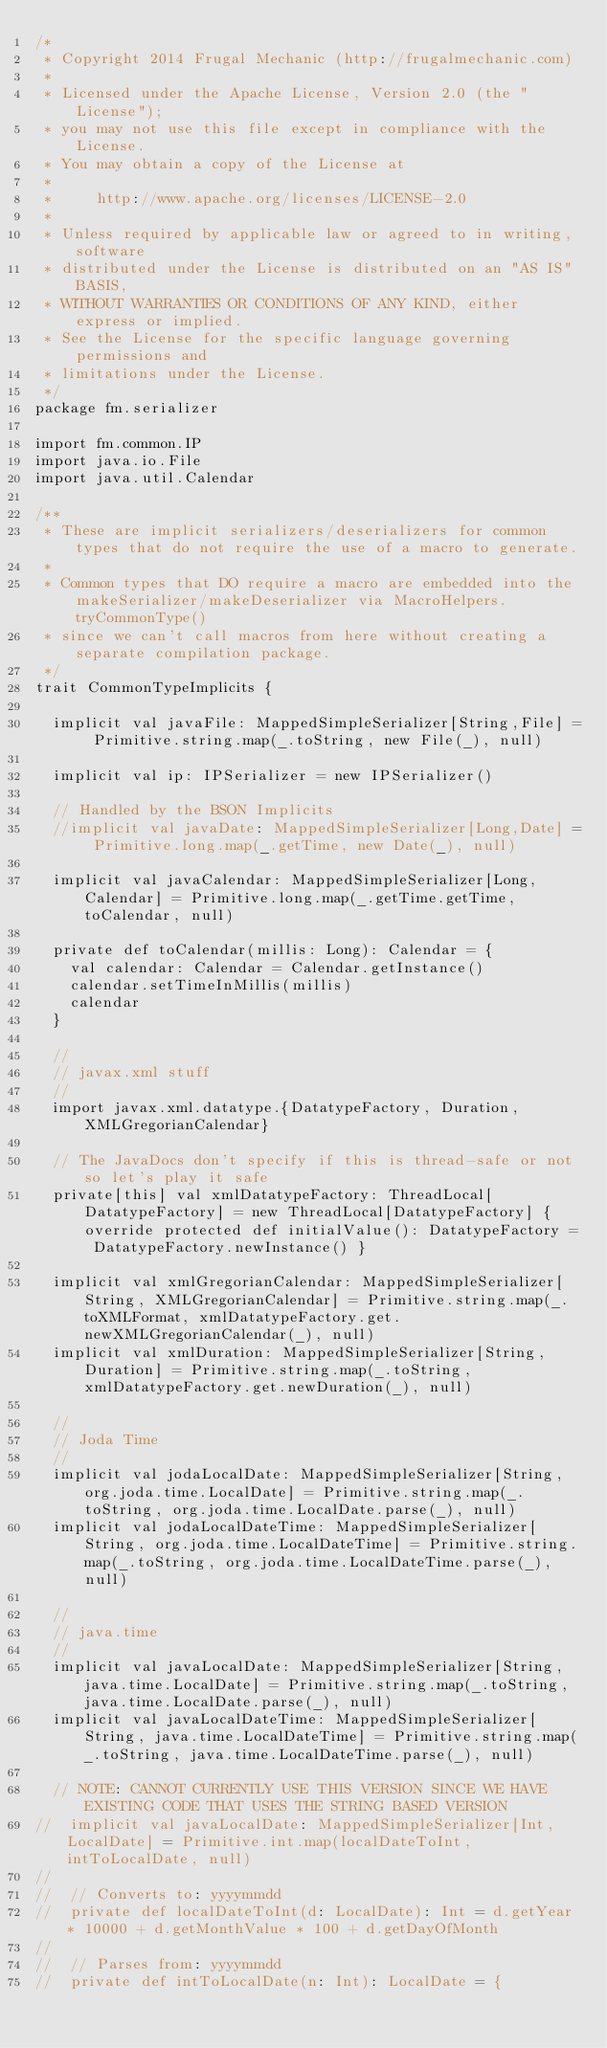<code> <loc_0><loc_0><loc_500><loc_500><_Scala_>/*
 * Copyright 2014 Frugal Mechanic (http://frugalmechanic.com)
 *
 * Licensed under the Apache License, Version 2.0 (the "License");
 * you may not use this file except in compliance with the License.
 * You may obtain a copy of the License at
 *
 *     http://www.apache.org/licenses/LICENSE-2.0
 *
 * Unless required by applicable law or agreed to in writing, software
 * distributed under the License is distributed on an "AS IS" BASIS,
 * WITHOUT WARRANTIES OR CONDITIONS OF ANY KIND, either express or implied.
 * See the License for the specific language governing permissions and
 * limitations under the License.
 */
package fm.serializer

import fm.common.IP
import java.io.File
import java.util.Calendar

/**
 * These are implicit serializers/deserializers for common types that do not require the use of a macro to generate.
 * 
 * Common types that DO require a macro are embedded into the makeSerializer/makeDeserializer via MacroHelpers.tryCommonType()
 * since we can't call macros from here without creating a separate compilation package.
 */
trait CommonTypeImplicits {

  implicit val javaFile: MappedSimpleSerializer[String,File] = Primitive.string.map(_.toString, new File(_), null)

  implicit val ip: IPSerializer = new IPSerializer()

  // Handled by the BSON Implicits
  //implicit val javaDate: MappedSimpleSerializer[Long,Date] = Primitive.long.map(_.getTime, new Date(_), null)

  implicit val javaCalendar: MappedSimpleSerializer[Long,Calendar] = Primitive.long.map(_.getTime.getTime, toCalendar, null)
  
  private def toCalendar(millis: Long): Calendar = {
    val calendar: Calendar = Calendar.getInstance()
    calendar.setTimeInMillis(millis)
    calendar
  }
  
  //
  // javax.xml stuff
  //
  import javax.xml.datatype.{DatatypeFactory, Duration, XMLGregorianCalendar}
  
  // The JavaDocs don't specify if this is thread-safe or not so let's play it safe
  private[this] val xmlDatatypeFactory: ThreadLocal[DatatypeFactory] = new ThreadLocal[DatatypeFactory] { override protected def initialValue(): DatatypeFactory = DatatypeFactory.newInstance() }
  
  implicit val xmlGregorianCalendar: MappedSimpleSerializer[String, XMLGregorianCalendar] = Primitive.string.map(_.toXMLFormat, xmlDatatypeFactory.get.newXMLGregorianCalendar(_), null)
  implicit val xmlDuration: MappedSimpleSerializer[String, Duration] = Primitive.string.map(_.toString, xmlDatatypeFactory.get.newDuration(_), null)
  
  //
  // Joda Time
  //  
  implicit val jodaLocalDate: MappedSimpleSerializer[String, org.joda.time.LocalDate] = Primitive.string.map(_.toString, org.joda.time.LocalDate.parse(_), null)
  implicit val jodaLocalDateTime: MappedSimpleSerializer[String, org.joda.time.LocalDateTime] = Primitive.string.map(_.toString, org.joda.time.LocalDateTime.parse(_), null)
  
  //
  // java.time
  //
  implicit val javaLocalDate: MappedSimpleSerializer[String, java.time.LocalDate] = Primitive.string.map(_.toString, java.time.LocalDate.parse(_), null)
  implicit val javaLocalDateTime: MappedSimpleSerializer[String, java.time.LocalDateTime] = Primitive.string.map(_.toString, java.time.LocalDateTime.parse(_), null)
  
  // NOTE: CANNOT CURRENTLY USE THIS VERSION SINCE WE HAVE EXISTING CODE THAT USES THE STRING BASED VERSION
//  implicit val javaLocalDate: MappedSimpleSerializer[Int,LocalDate] = Primitive.int.map(localDateToInt, intToLocalDate, null)
//  
//  // Converts to: yyyymmdd
//  private def localDateToInt(d: LocalDate): Int = d.getYear * 10000 + d.getMonthValue * 100 + d.getDayOfMonth
//  
//  // Parses from: yyyymmdd
//  private def intToLocalDate(n: Int): LocalDate = {</code> 